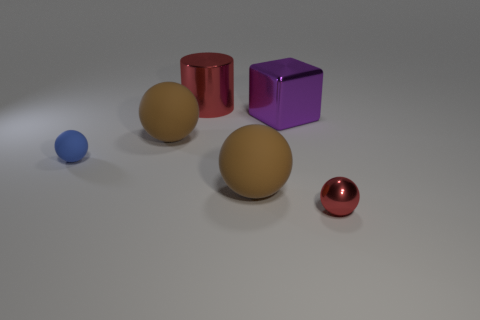Subtract all blue balls. How many balls are left? 3 Add 2 big red things. How many objects exist? 8 Subtract all cyan balls. Subtract all green cylinders. How many balls are left? 4 Subtract all blocks. How many objects are left? 5 Add 3 big brown balls. How many big brown balls exist? 5 Subtract 0 yellow balls. How many objects are left? 6 Subtract all large rubber cylinders. Subtract all tiny balls. How many objects are left? 4 Add 5 blue matte objects. How many blue matte objects are left? 6 